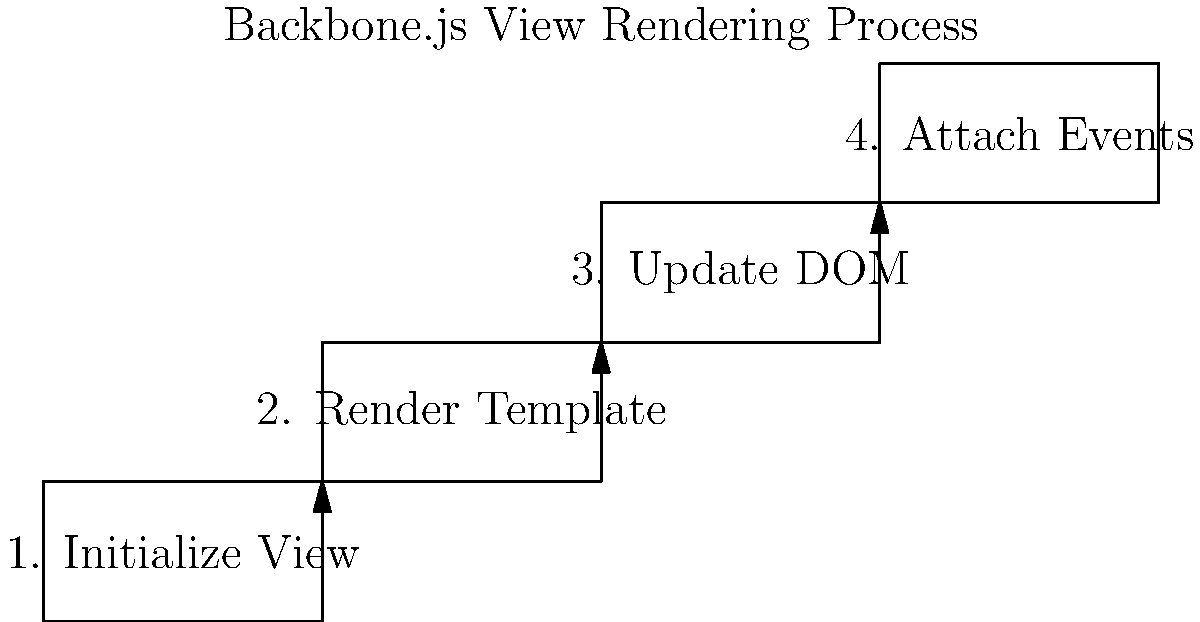In the Backbone.js view rendering process shown above, which step immediately follows the "Render Template" phase? The Backbone.js view rendering process typically follows these steps:

1. Initialize View: The view object is created and initialized with any necessary data or options.

2. Render Template: The view's template is rendered, usually using a templating engine like Underscore.js or Handlebars.

3. Update DOM: The rendered template is inserted into the DOM, replacing or updating the existing content.

4. Attach Events: Event listeners are attached to elements within the view, allowing for user interaction.

Looking at the diagram, we can see that the steps are arranged in a sequential order from left to right and bottom to top. The "Render Template" step is the second box in this sequence. The arrow from this box leads directly to the next step, which is "Update DOM".

Therefore, the step that immediately follows the "Render Template" phase is "Update DOM".
Answer: Update DOM 